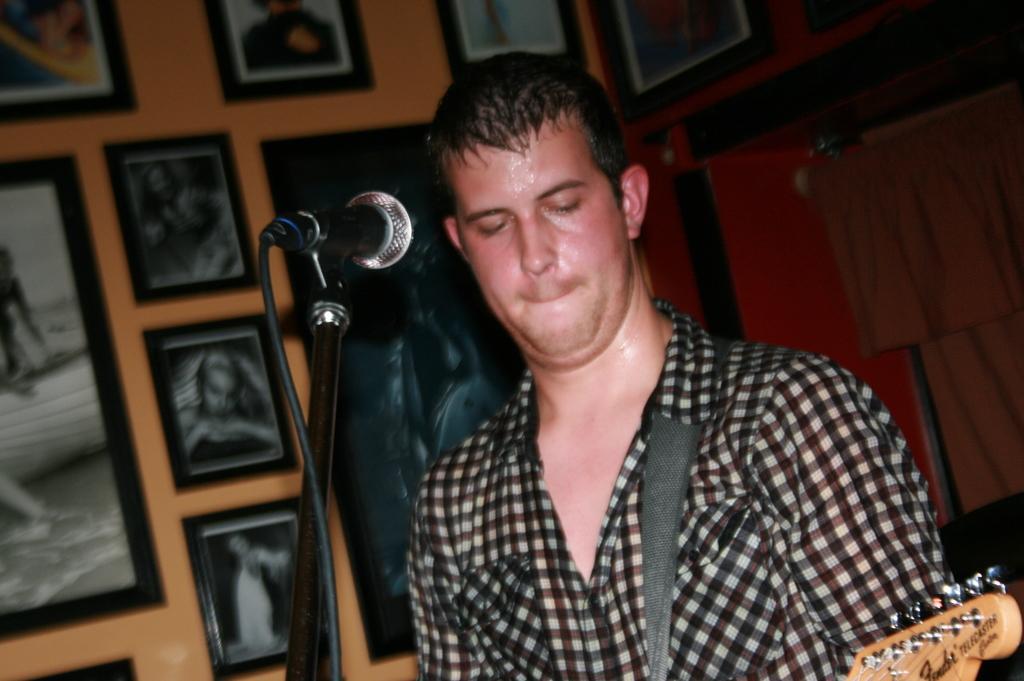Please provide a concise description of this image. As we can see in the image there is a man and a mike and a orange color wall. On wall there are few photo frames. 